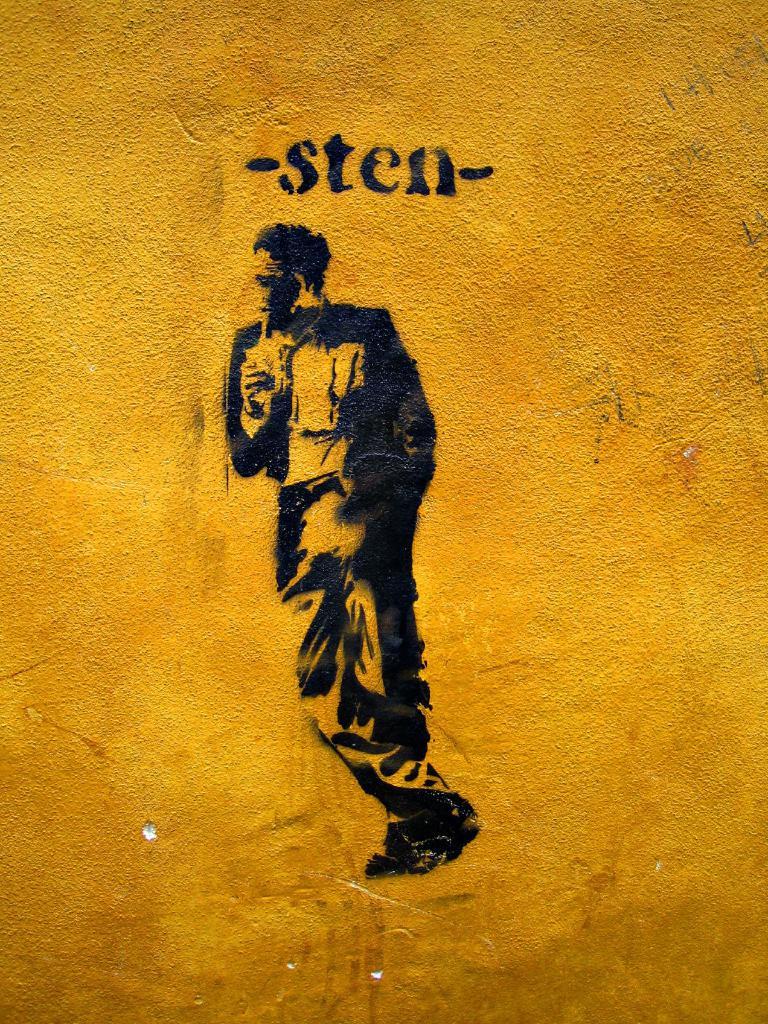What is the name of the person?
Provide a succinct answer. Sten. 